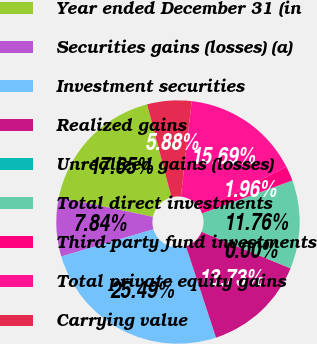Convert chart to OTSL. <chart><loc_0><loc_0><loc_500><loc_500><pie_chart><fcel>Year ended December 31 (in<fcel>Securities gains (losses) (a)<fcel>Investment securities<fcel>Realized gains<fcel>Unrealized gains (losses)<fcel>Total direct investments<fcel>Third-party fund investments<fcel>Total private equity gains<fcel>Carrying value<nl><fcel>17.65%<fcel>7.84%<fcel>25.49%<fcel>13.73%<fcel>0.0%<fcel>11.76%<fcel>1.96%<fcel>15.69%<fcel>5.88%<nl></chart> 